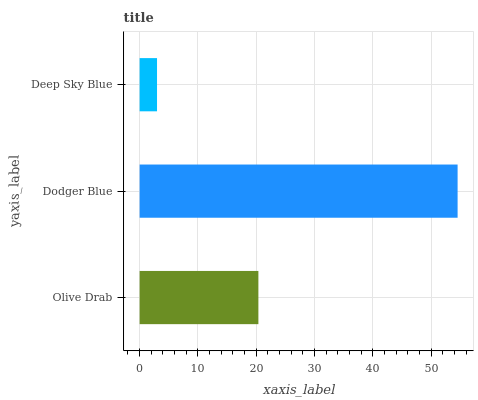Is Deep Sky Blue the minimum?
Answer yes or no. Yes. Is Dodger Blue the maximum?
Answer yes or no. Yes. Is Dodger Blue the minimum?
Answer yes or no. No. Is Deep Sky Blue the maximum?
Answer yes or no. No. Is Dodger Blue greater than Deep Sky Blue?
Answer yes or no. Yes. Is Deep Sky Blue less than Dodger Blue?
Answer yes or no. Yes. Is Deep Sky Blue greater than Dodger Blue?
Answer yes or no. No. Is Dodger Blue less than Deep Sky Blue?
Answer yes or no. No. Is Olive Drab the high median?
Answer yes or no. Yes. Is Olive Drab the low median?
Answer yes or no. Yes. Is Deep Sky Blue the high median?
Answer yes or no. No. Is Dodger Blue the low median?
Answer yes or no. No. 